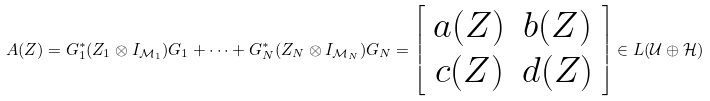<formula> <loc_0><loc_0><loc_500><loc_500>A ( Z ) = G _ { 1 } ^ { * } ( Z _ { 1 } \otimes I _ { \mathcal { M } _ { 1 } } ) G _ { 1 } + \cdots + G _ { N } ^ { * } ( Z _ { N } \otimes I _ { \mathcal { M } _ { N } } ) G _ { N } = \left [ \begin{array} { c c } a ( Z ) & b ( Z ) \\ c ( Z ) & d ( Z ) \end{array} \right ] \in L ( \mathcal { U \oplus H } )</formula> 